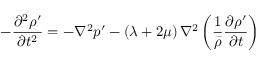<formula> <loc_0><loc_0><loc_500><loc_500>- \frac { \partial ^ { 2 } \rho ^ { \prime } } { \partial t ^ { 2 } } = - \nabla ^ { 2 } p ^ { \prime } - \left ( \lambda + 2 \mu \right ) \nabla ^ { 2 } \left ( \frac { 1 } { \bar { \rho } } \frac { \partial \rho ^ { \prime } } { \partial t } \right )</formula> 